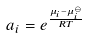Convert formula to latex. <formula><loc_0><loc_0><loc_500><loc_500>a _ { i } = e ^ { \frac { \mu _ { i } - \mu _ { i } ^ { \ominus } } { R T } }</formula> 